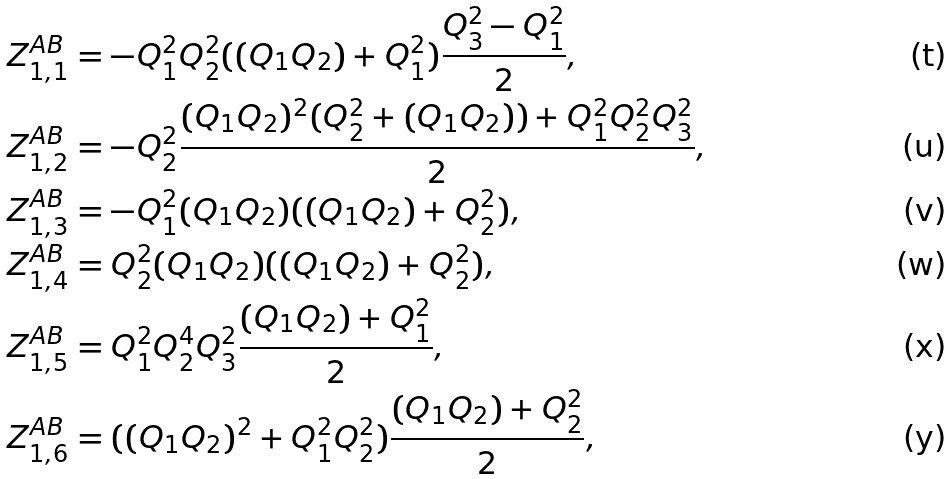Convert formula to latex. <formula><loc_0><loc_0><loc_500><loc_500>& Z ^ { A B } _ { 1 , 1 } = - Q _ { 1 } ^ { 2 } Q _ { 2 } ^ { 2 } ( ( Q _ { 1 } Q _ { 2 } ) + Q _ { 1 } ^ { 2 } ) \frac { Q _ { 3 } ^ { 2 } - Q _ { 1 } ^ { 2 } } { 2 } , \quad \\ & Z ^ { A B } _ { 1 , 2 } = - Q _ { 2 } ^ { 2 } \frac { ( Q _ { 1 } Q _ { 2 } ) ^ { 2 } ( Q _ { 2 } ^ { 2 } + ( Q _ { 1 } Q _ { 2 } ) ) + Q _ { 1 } ^ { 2 } Q _ { 2 } ^ { 2 } Q _ { 3 } ^ { 2 } } { 2 } , \quad \\ & Z ^ { A B } _ { 1 , 3 } = - Q _ { 1 } ^ { 2 } ( Q _ { 1 } Q _ { 2 } ) ( ( Q _ { 1 } Q _ { 2 } ) + Q _ { 2 } ^ { 2 } ) , \quad \\ & Z ^ { A B } _ { 1 , 4 } = Q _ { 2 } ^ { 2 } ( Q _ { 1 } Q _ { 2 } ) ( ( Q _ { 1 } Q _ { 2 } ) + Q _ { 2 } ^ { 2 } ) , \quad \\ & Z ^ { A B } _ { 1 , 5 } = Q _ { 1 } ^ { 2 } Q _ { 2 } ^ { 4 } Q _ { 3 } ^ { 2 } \frac { ( Q _ { 1 } Q _ { 2 } ) + Q _ { 1 } ^ { 2 } } { 2 } , \quad \\ & Z ^ { A B } _ { 1 , 6 } = ( ( Q _ { 1 } Q _ { 2 } ) ^ { 2 } + Q _ { 1 } ^ { 2 } Q _ { 2 } ^ { 2 } ) \frac { ( Q _ { 1 } Q _ { 2 } ) + Q _ { 2 } ^ { 2 } } { 2 } ,</formula> 